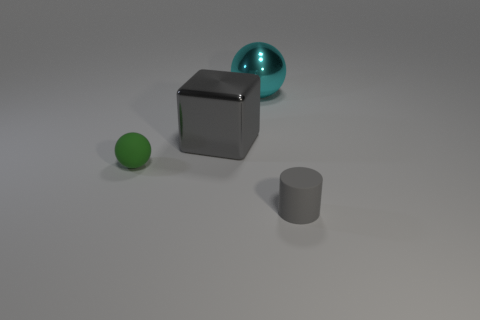Add 1 large metal spheres. How many objects exist? 5 Subtract all blocks. How many objects are left? 3 Subtract 0 brown cubes. How many objects are left? 4 Subtract all purple matte blocks. Subtract all green matte spheres. How many objects are left? 3 Add 3 gray metallic things. How many gray metallic things are left? 4 Add 3 big purple objects. How many big purple objects exist? 3 